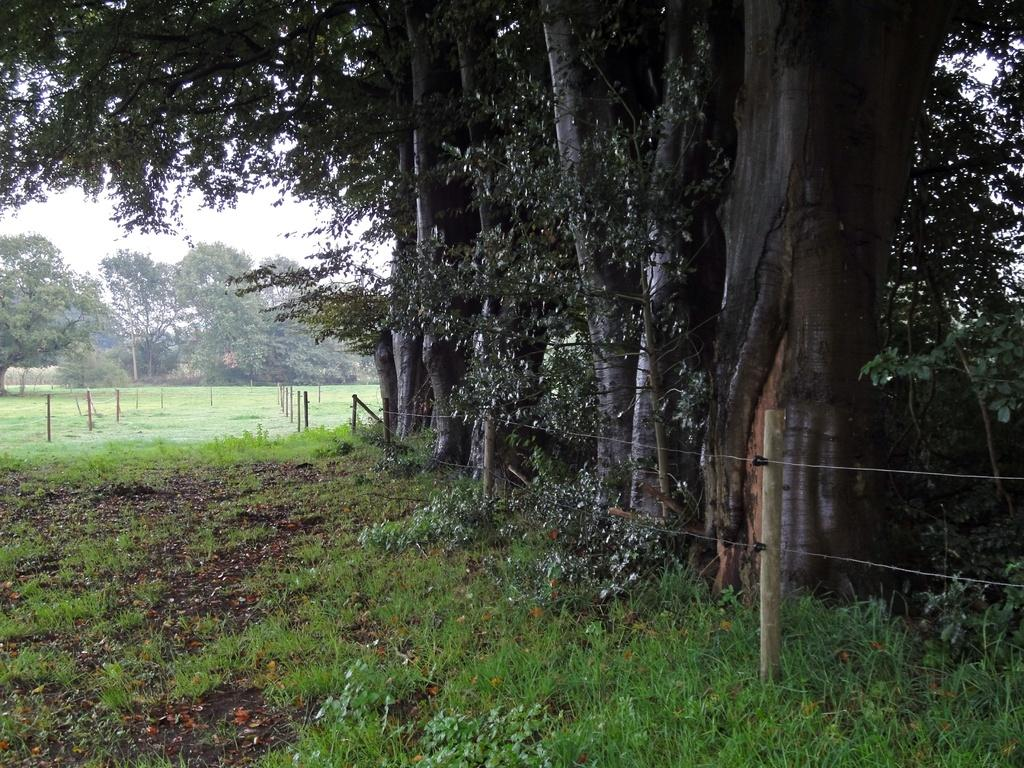What type of surface can be seen in the image? There is ground visible in the image. What covers the ground in the image? There is grass on the ground. What structures are present in the image? There are wooden poles and fencing in the image. What type of vegetation is present in the image? There are green trees in the image. What is visible in the background of the image? The sky is visible in the background of the image. What type of straw is being used to decorate the trees in the image? There is no straw present in the image, and the trees are not decorated. How many cherries can be seen hanging from the wooden poles in the image? There are no cherries present in the image; only wooden poles and fencing are visible. 